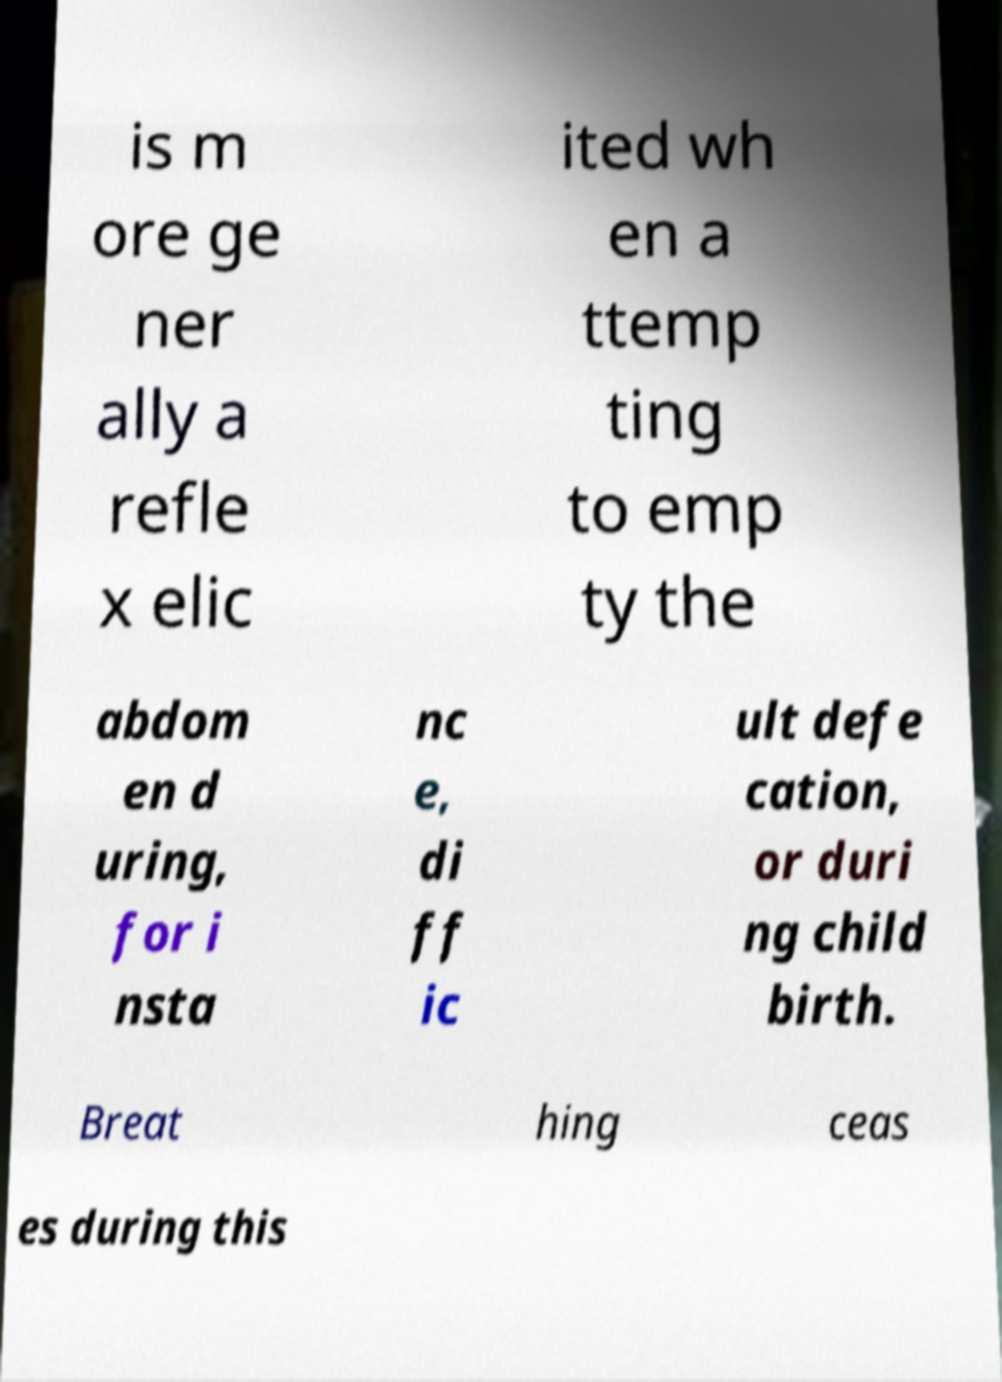Can you read and provide the text displayed in the image?This photo seems to have some interesting text. Can you extract and type it out for me? is m ore ge ner ally a refle x elic ited wh en a ttemp ting to emp ty the abdom en d uring, for i nsta nc e, di ff ic ult defe cation, or duri ng child birth. Breat hing ceas es during this 